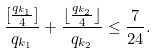<formula> <loc_0><loc_0><loc_500><loc_500>\frac { [ \frac { q _ { k _ { 1 } } } 4 ] } { q _ { k _ { 1 } } } + \frac { \lfloor \frac { q _ { k _ { 2 } } } 4 \rfloor } { q _ { k _ { 2 } } } \leq \frac { 7 } { 2 4 } .</formula> 